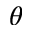Convert formula to latex. <formula><loc_0><loc_0><loc_500><loc_500>\theta</formula> 